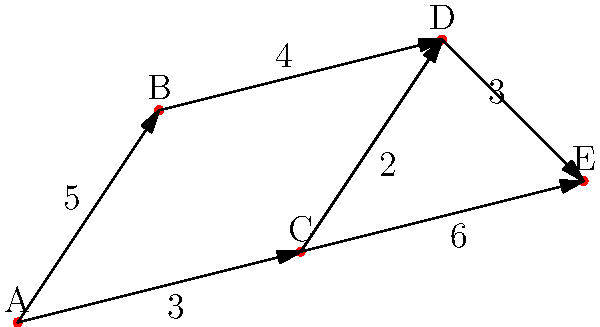The diagram represents a network of grazing grounds (A, B, C, D, E) for reindeer herds. The numbers on the edges indicate the travel time in days between the connected grazing grounds. What is the minimum number of days required to travel from grazing ground A to grazing ground E? To find the minimum number of days required to travel from A to E, we need to consider all possible paths and their total travel times:

1. Path A → B → D → E:
   A to B: 5 days
   B to D: 4 days
   D to E: 3 days
   Total: 5 + 4 + 3 = 12 days

2. Path A → C → D → E:
   A to C: 3 days
   C to D: 2 days
   D to E: 3 days
   Total: 3 + 2 + 3 = 8 days

3. Path A → C → E:
   A to C: 3 days
   C to E: 6 days
   Total: 3 + 6 = 9 days

The path with the minimum travel time is A → C → D → E, which takes 8 days.
Answer: 8 days 